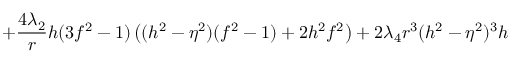Convert formula to latex. <formula><loc_0><loc_0><loc_500><loc_500>+ \frac { 4 \lambda _ { 2 } } { r } h ( 3 f ^ { 2 } - 1 ) \left ( ( h ^ { 2 } - \eta ^ { 2 } ) ( f ^ { 2 } - 1 ) + 2 h ^ { 2 } f ^ { 2 } \right ) + 2 \lambda _ { 4 } r ^ { 3 } ( h ^ { 2 } - \eta ^ { 2 } ) ^ { 3 } h</formula> 